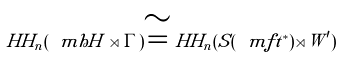<formula> <loc_0><loc_0><loc_500><loc_500>H H _ { n } ( \ m h H \rtimes \Gamma ) \cong H H _ { n } ( S ( \ m f t ^ { * } ) \rtimes W ^ { \prime } )</formula> 